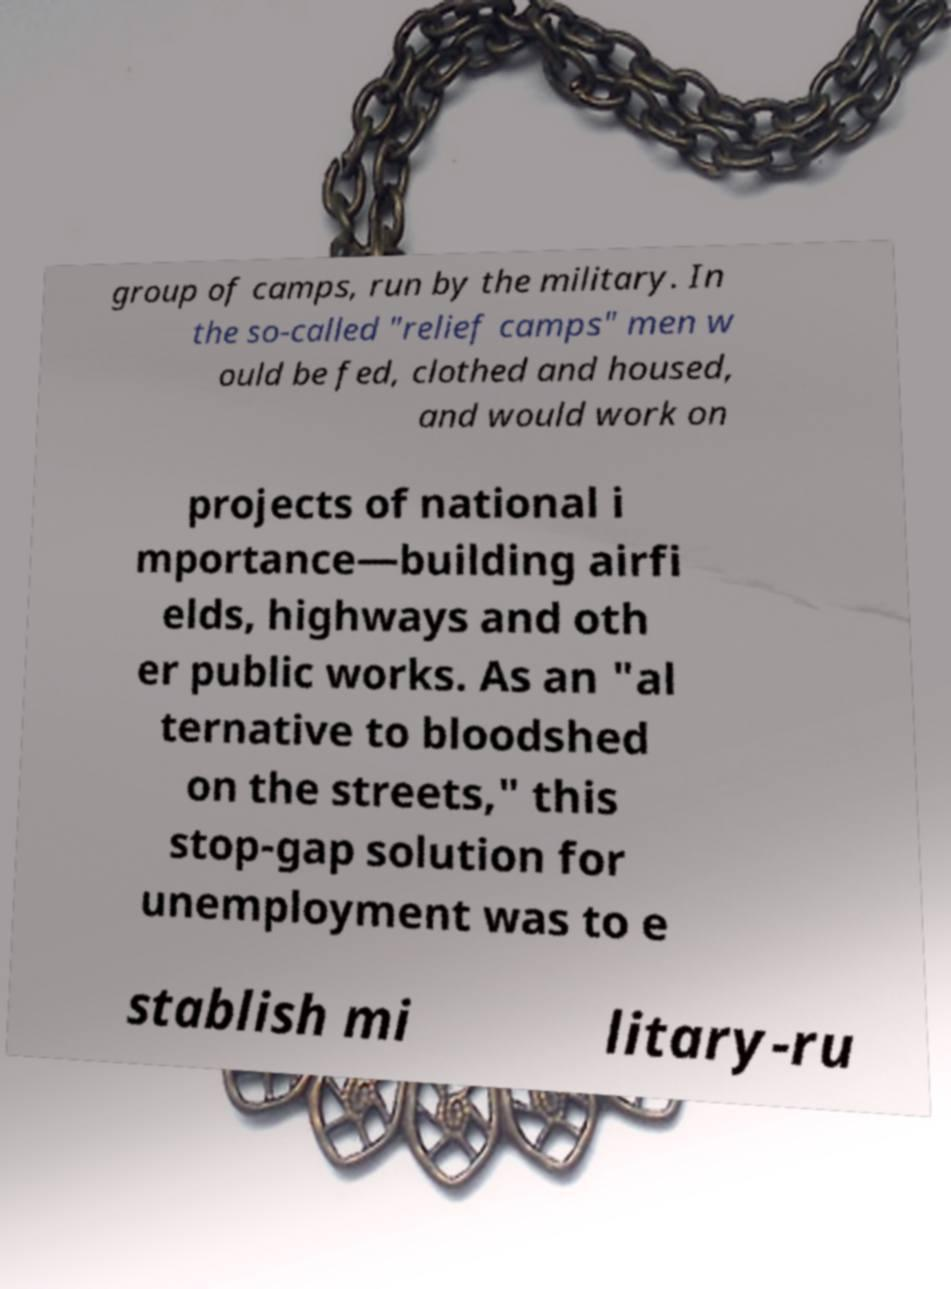There's text embedded in this image that I need extracted. Can you transcribe it verbatim? group of camps, run by the military. In the so-called "relief camps" men w ould be fed, clothed and housed, and would work on projects of national i mportance—building airfi elds, highways and oth er public works. As an "al ternative to bloodshed on the streets," this stop-gap solution for unemployment was to e stablish mi litary-ru 